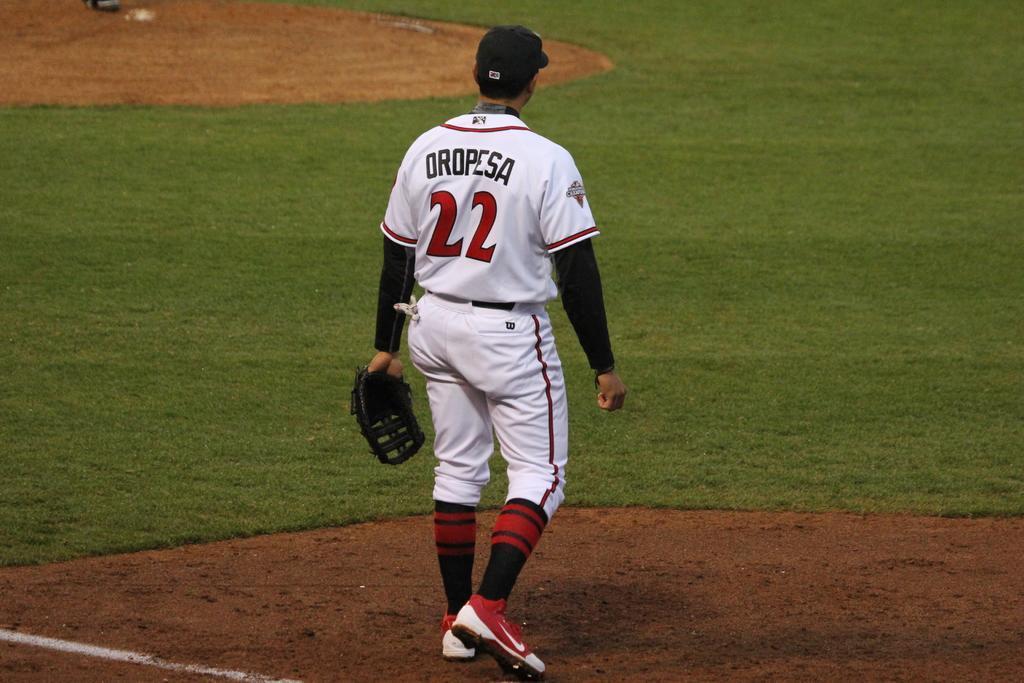<image>
Render a clear and concise summary of the photo. A baseball player with the name Oropesa written on his back 